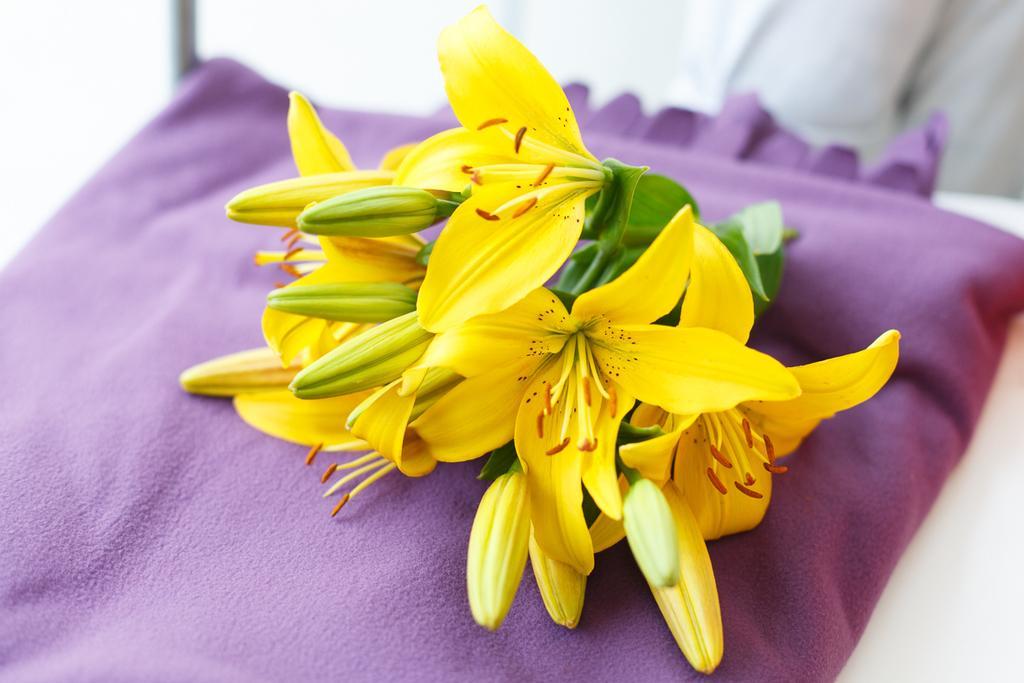Can you describe this image briefly? In the center of the image, we can see flowers, leaves and buds on the cloth and at the bottom, there is table. 